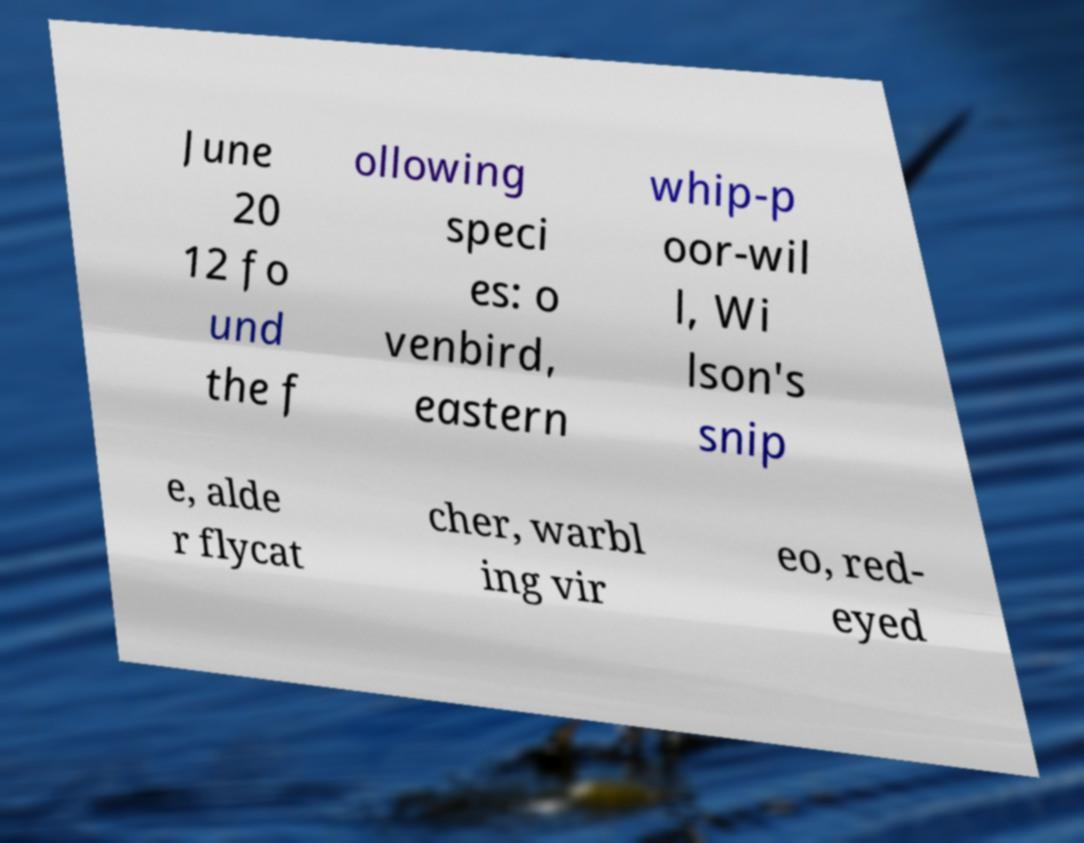Could you extract and type out the text from this image? June 20 12 fo und the f ollowing speci es: o venbird, eastern whip-p oor-wil l, Wi lson's snip e, alde r flycat cher, warbl ing vir eo, red- eyed 